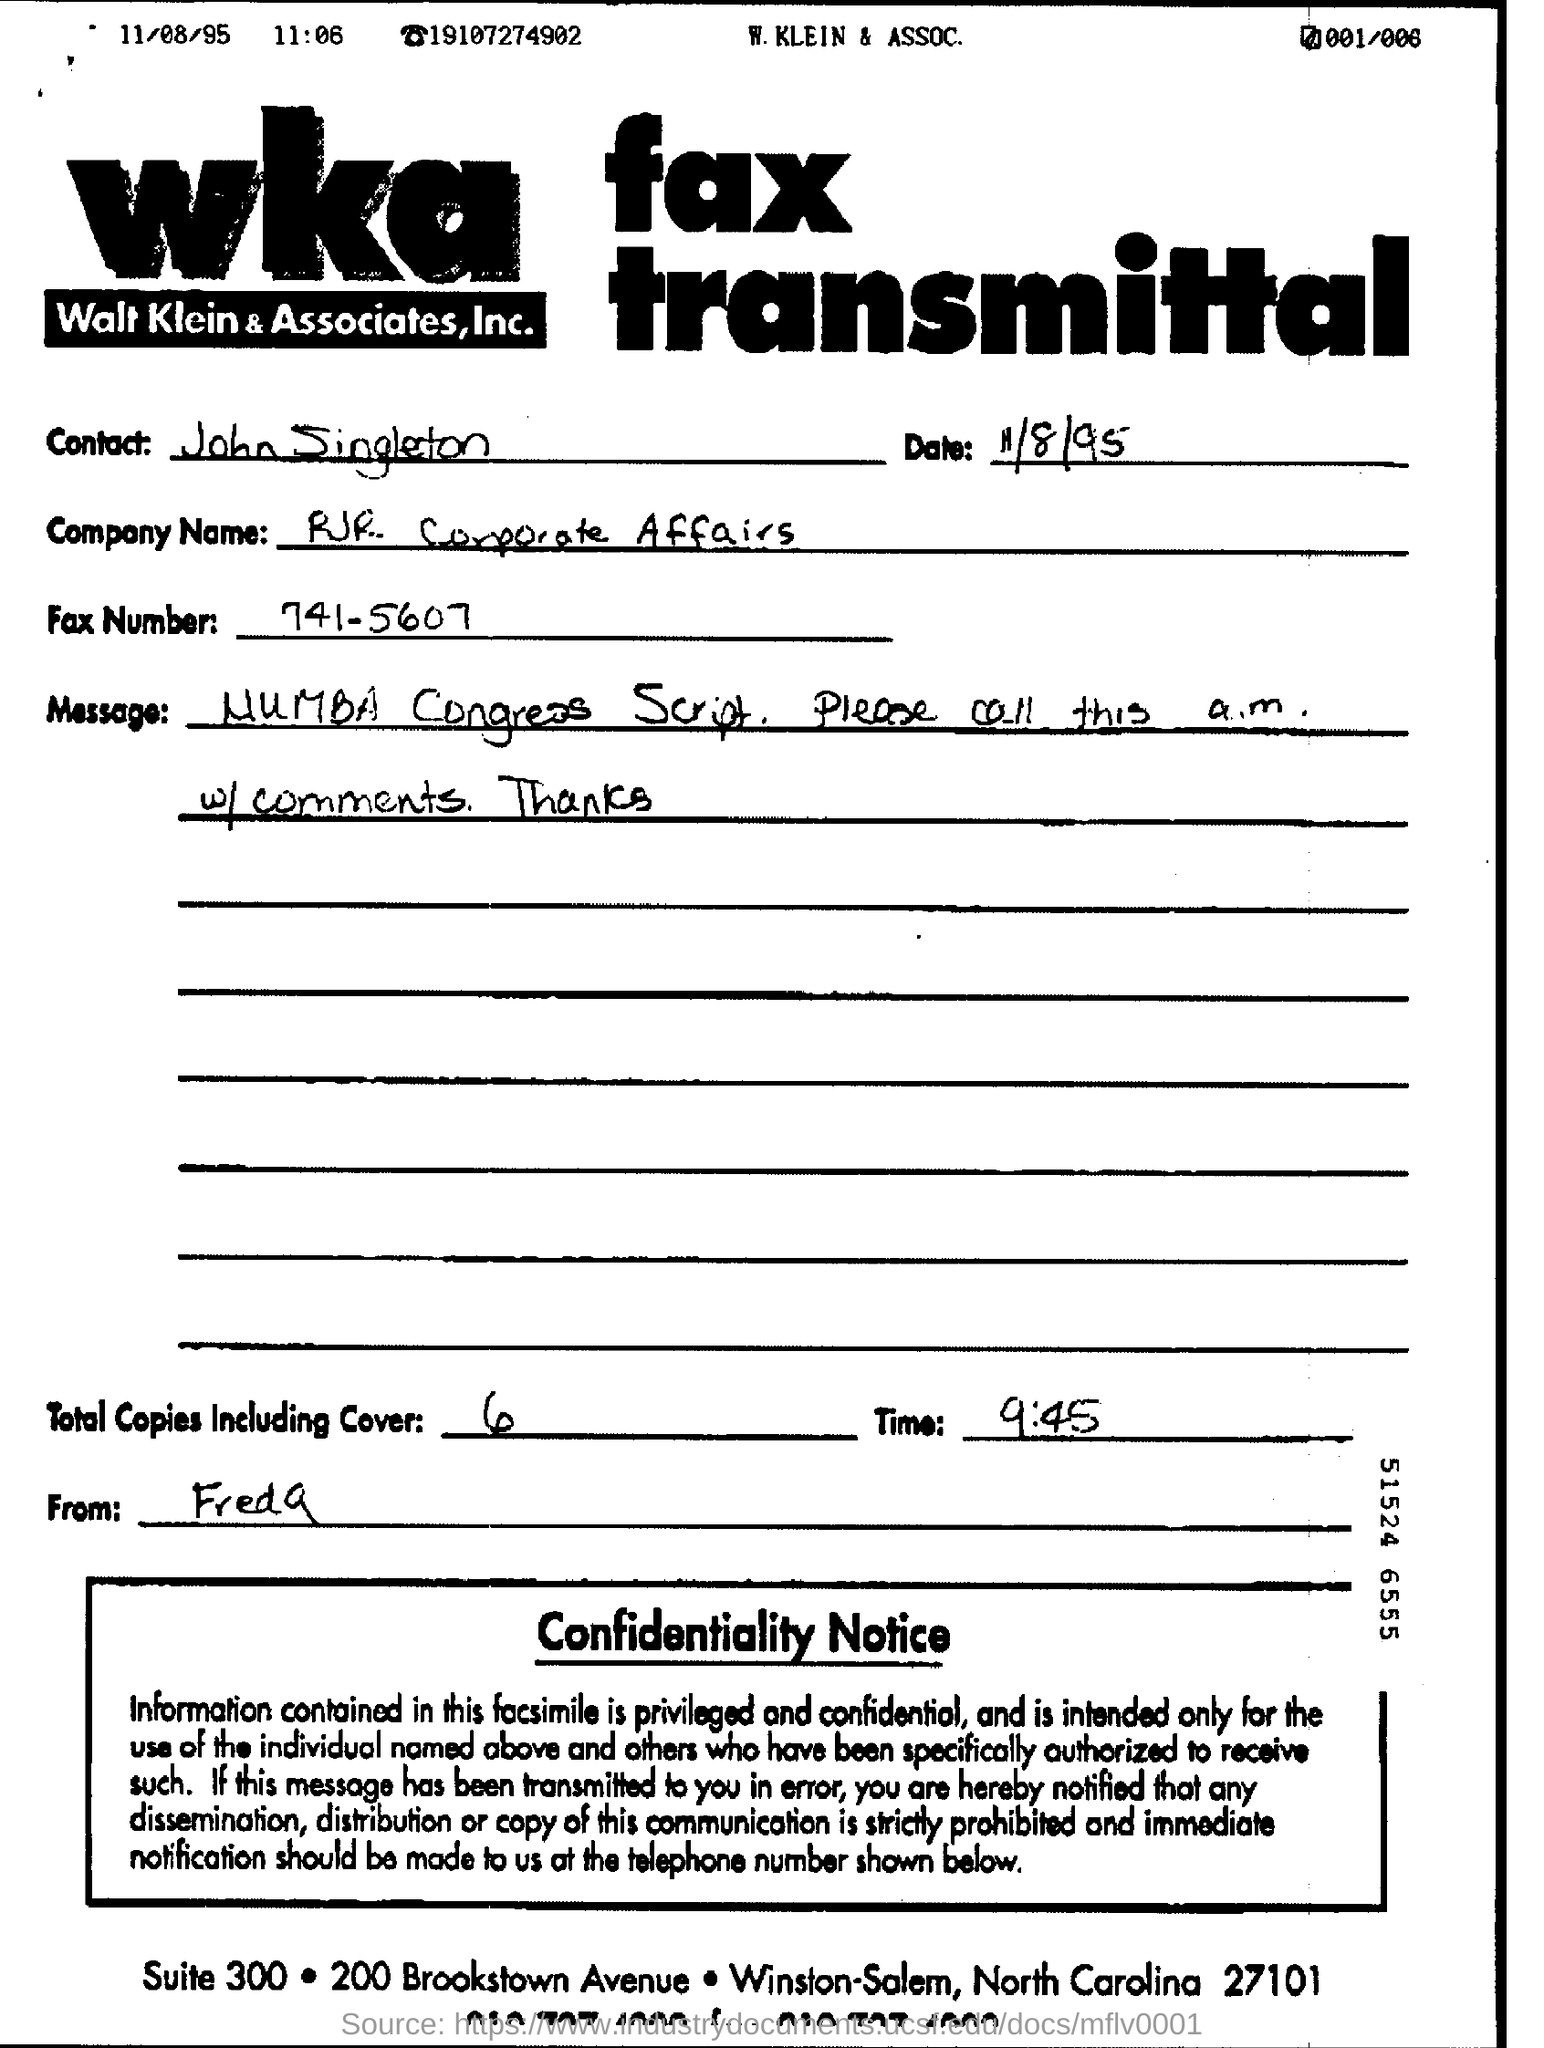Identify some key points in this picture. The contact is John singleton. The company name is RJR corporate affairs. The date on the fax is November 8th, 1995. The question of what the fax number is is 741-5607.. 